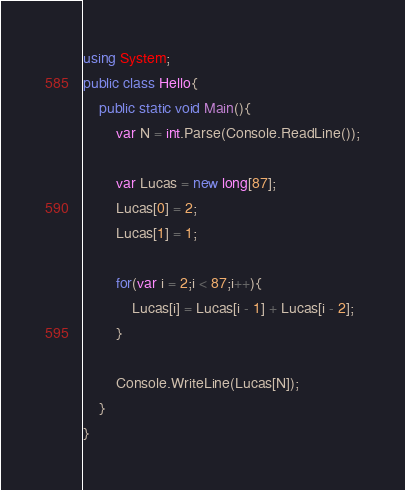<code> <loc_0><loc_0><loc_500><loc_500><_C#_>using System;
public class Hello{
    public static void Main(){
        var N = int.Parse(Console.ReadLine());
        
        var Lucas = new long[87];
        Lucas[0] = 2;
        Lucas[1] = 1;
        
        for(var i = 2;i < 87;i++){
            Lucas[i] = Lucas[i - 1] + Lucas[i - 2];
        }
        
        Console.WriteLine(Lucas[N]);
    }
}
</code> 